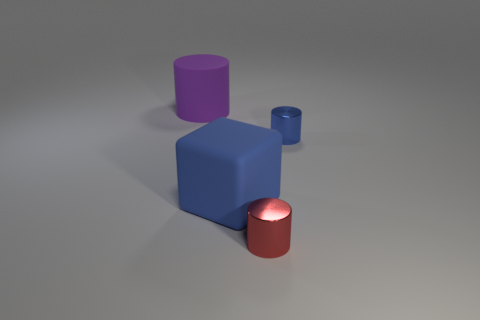Subtract all big cylinders. How many cylinders are left? 2 Subtract 0 gray blocks. How many objects are left? 4 Subtract all cubes. How many objects are left? 3 Subtract 1 cylinders. How many cylinders are left? 2 Subtract all purple blocks. Subtract all brown cylinders. How many blocks are left? 1 Subtract all brown cylinders. How many gray blocks are left? 0 Subtract all big rubber cubes. Subtract all metal objects. How many objects are left? 1 Add 1 small cylinders. How many small cylinders are left? 3 Add 1 brown shiny spheres. How many brown shiny spheres exist? 1 Add 2 small red metallic cubes. How many objects exist? 6 